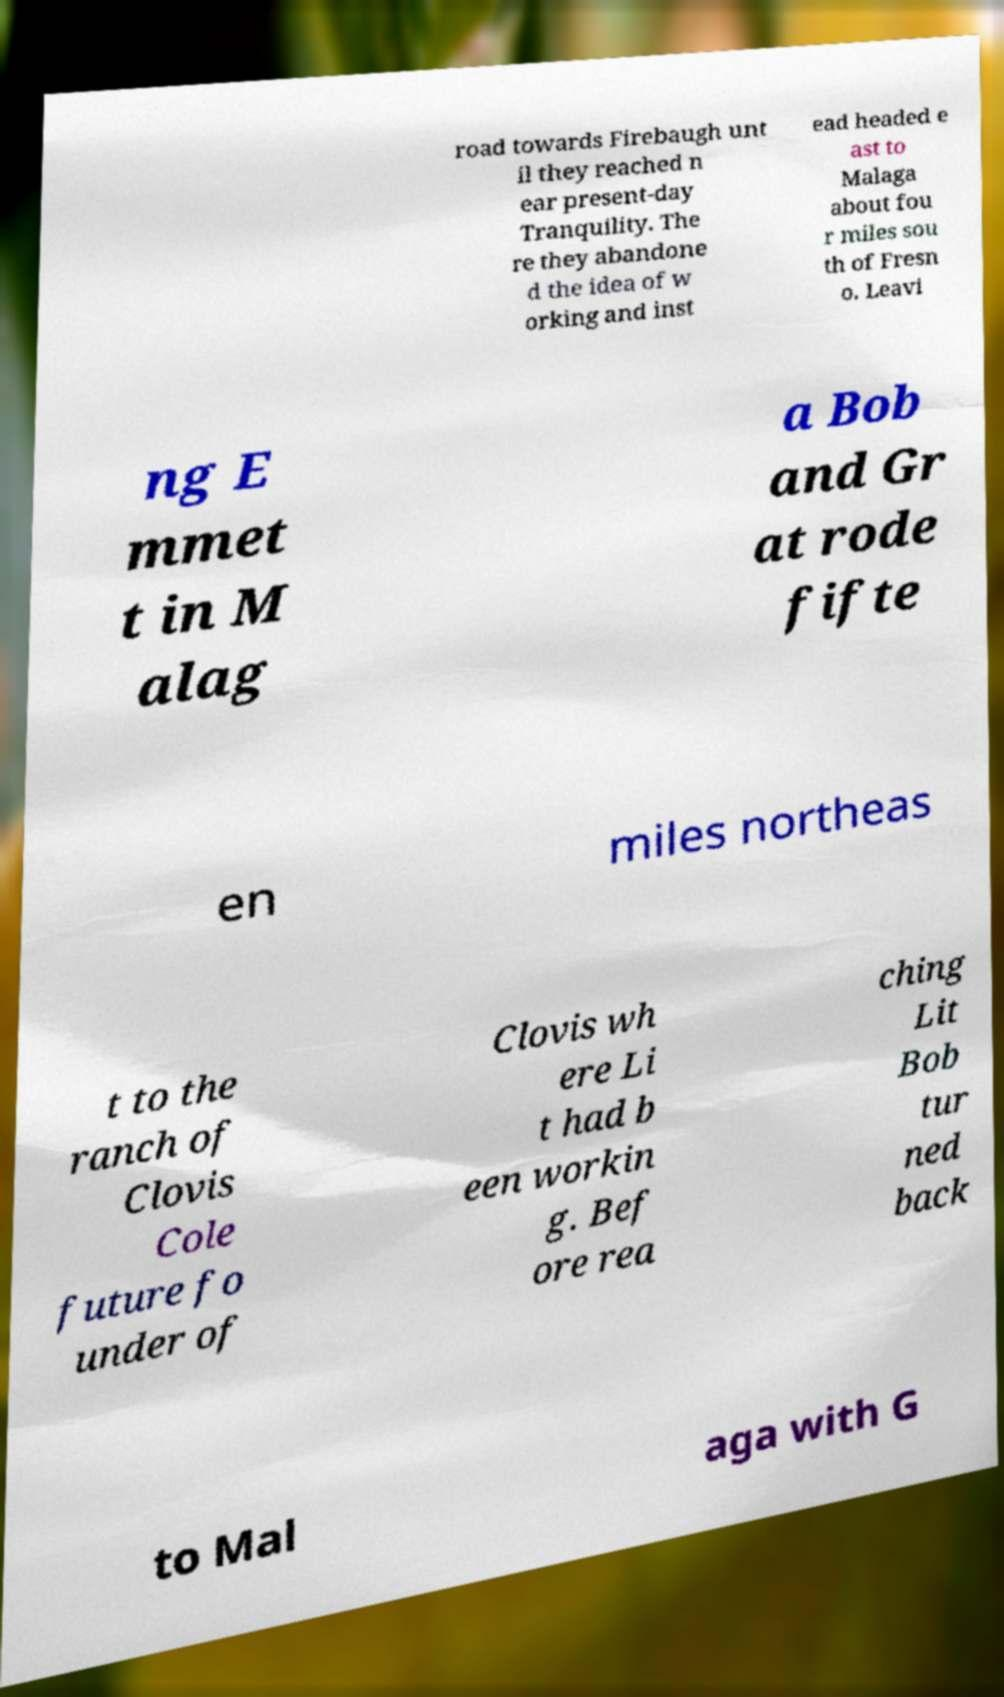Can you accurately transcribe the text from the provided image for me? road towards Firebaugh unt il they reached n ear present-day Tranquility. The re they abandone d the idea of w orking and inst ead headed e ast to Malaga about fou r miles sou th of Fresn o. Leavi ng E mmet t in M alag a Bob and Gr at rode fifte en miles northeas t to the ranch of Clovis Cole future fo under of Clovis wh ere Li t had b een workin g. Bef ore rea ching Lit Bob tur ned back to Mal aga with G 